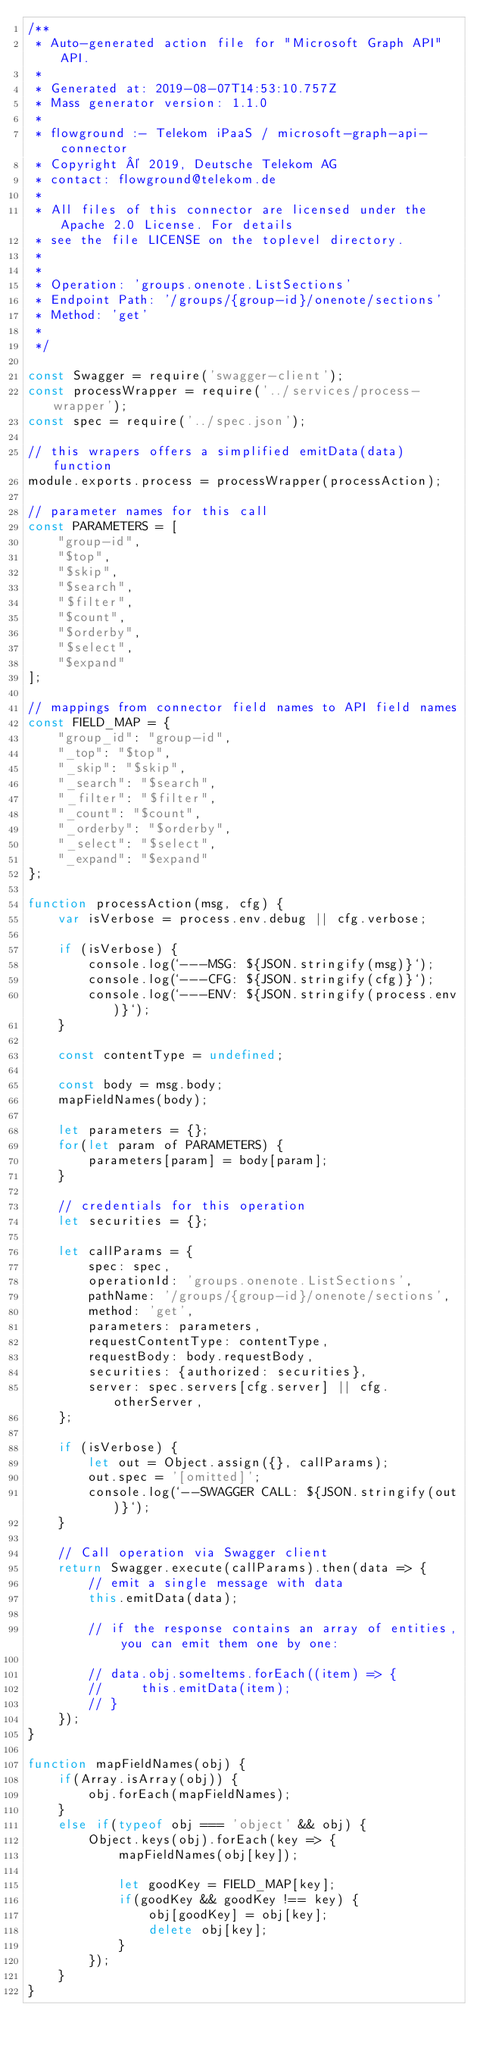<code> <loc_0><loc_0><loc_500><loc_500><_JavaScript_>/**
 * Auto-generated action file for "Microsoft Graph API" API.
 *
 * Generated at: 2019-08-07T14:53:10.757Z
 * Mass generator version: 1.1.0
 *
 * flowground :- Telekom iPaaS / microsoft-graph-api-connector
 * Copyright © 2019, Deutsche Telekom AG
 * contact: flowground@telekom.de
 *
 * All files of this connector are licensed under the Apache 2.0 License. For details
 * see the file LICENSE on the toplevel directory.
 *
 *
 * Operation: 'groups.onenote.ListSections'
 * Endpoint Path: '/groups/{group-id}/onenote/sections'
 * Method: 'get'
 *
 */

const Swagger = require('swagger-client');
const processWrapper = require('../services/process-wrapper');
const spec = require('../spec.json');

// this wrapers offers a simplified emitData(data) function
module.exports.process = processWrapper(processAction);

// parameter names for this call
const PARAMETERS = [
    "group-id",
    "$top",
    "$skip",
    "$search",
    "$filter",
    "$count",
    "$orderby",
    "$select",
    "$expand"
];

// mappings from connector field names to API field names
const FIELD_MAP = {
    "group_id": "group-id",
    "_top": "$top",
    "_skip": "$skip",
    "_search": "$search",
    "_filter": "$filter",
    "_count": "$count",
    "_orderby": "$orderby",
    "_select": "$select",
    "_expand": "$expand"
};

function processAction(msg, cfg) {
    var isVerbose = process.env.debug || cfg.verbose;

    if (isVerbose) {
        console.log(`---MSG: ${JSON.stringify(msg)}`);
        console.log(`---CFG: ${JSON.stringify(cfg)}`);
        console.log(`---ENV: ${JSON.stringify(process.env)}`);
    }

    const contentType = undefined;

    const body = msg.body;
    mapFieldNames(body);

    let parameters = {};
    for(let param of PARAMETERS) {
        parameters[param] = body[param];
    }

    // credentials for this operation
    let securities = {};

    let callParams = {
        spec: spec,
        operationId: 'groups.onenote.ListSections',
        pathName: '/groups/{group-id}/onenote/sections',
        method: 'get',
        parameters: parameters,
        requestContentType: contentType,
        requestBody: body.requestBody,
        securities: {authorized: securities},
        server: spec.servers[cfg.server] || cfg.otherServer,
    };

    if (isVerbose) {
        let out = Object.assign({}, callParams);
        out.spec = '[omitted]';
        console.log(`--SWAGGER CALL: ${JSON.stringify(out)}`);
    }

    // Call operation via Swagger client
    return Swagger.execute(callParams).then(data => {
        // emit a single message with data
        this.emitData(data);

        // if the response contains an array of entities, you can emit them one by one:

        // data.obj.someItems.forEach((item) => {
        //     this.emitData(item);
        // }
    });
}

function mapFieldNames(obj) {
    if(Array.isArray(obj)) {
        obj.forEach(mapFieldNames);
    }
    else if(typeof obj === 'object' && obj) {
        Object.keys(obj).forEach(key => {
            mapFieldNames(obj[key]);

            let goodKey = FIELD_MAP[key];
            if(goodKey && goodKey !== key) {
                obj[goodKey] = obj[key];
                delete obj[key];
            }
        });
    }
}</code> 